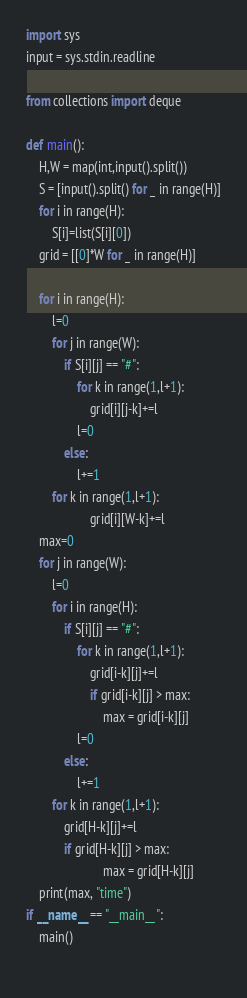<code> <loc_0><loc_0><loc_500><loc_500><_Python_>import sys
input = sys.stdin.readline

from collections import deque

def main(): 
    H,W = map(int,input().split())
    S = [input().split() for _ in range(H)]
    for i in range(H):
        S[i]=list(S[i][0])
    grid = [[0]*W for _ in range(H)]
    
    for i in range(H):
        l=0
        for j in range(W):
            if S[i][j] == "#":
                for k in range(1,l+1):
                    grid[i][j-k]+=l
                l=0
            else:
                l+=1
        for k in range(1,l+1):
                    grid[i][W-k]+=l
    max=0
    for j in range(W):
        l=0
        for i in range(H):
            if S[i][j] == "#":
                for k in range(1,l+1):
                    grid[i-k][j]+=l
                    if grid[i-k][j] > max:
                        max = grid[i-k][j]
                l=0
            else:
                l+=1
        for k in range(1,l+1):
            grid[H-k][j]+=l
            if grid[H-k][j] > max:
                        max = grid[H-k][j]
    print(max, "time")
if __name__ == "__main__":
    main()
    </code> 